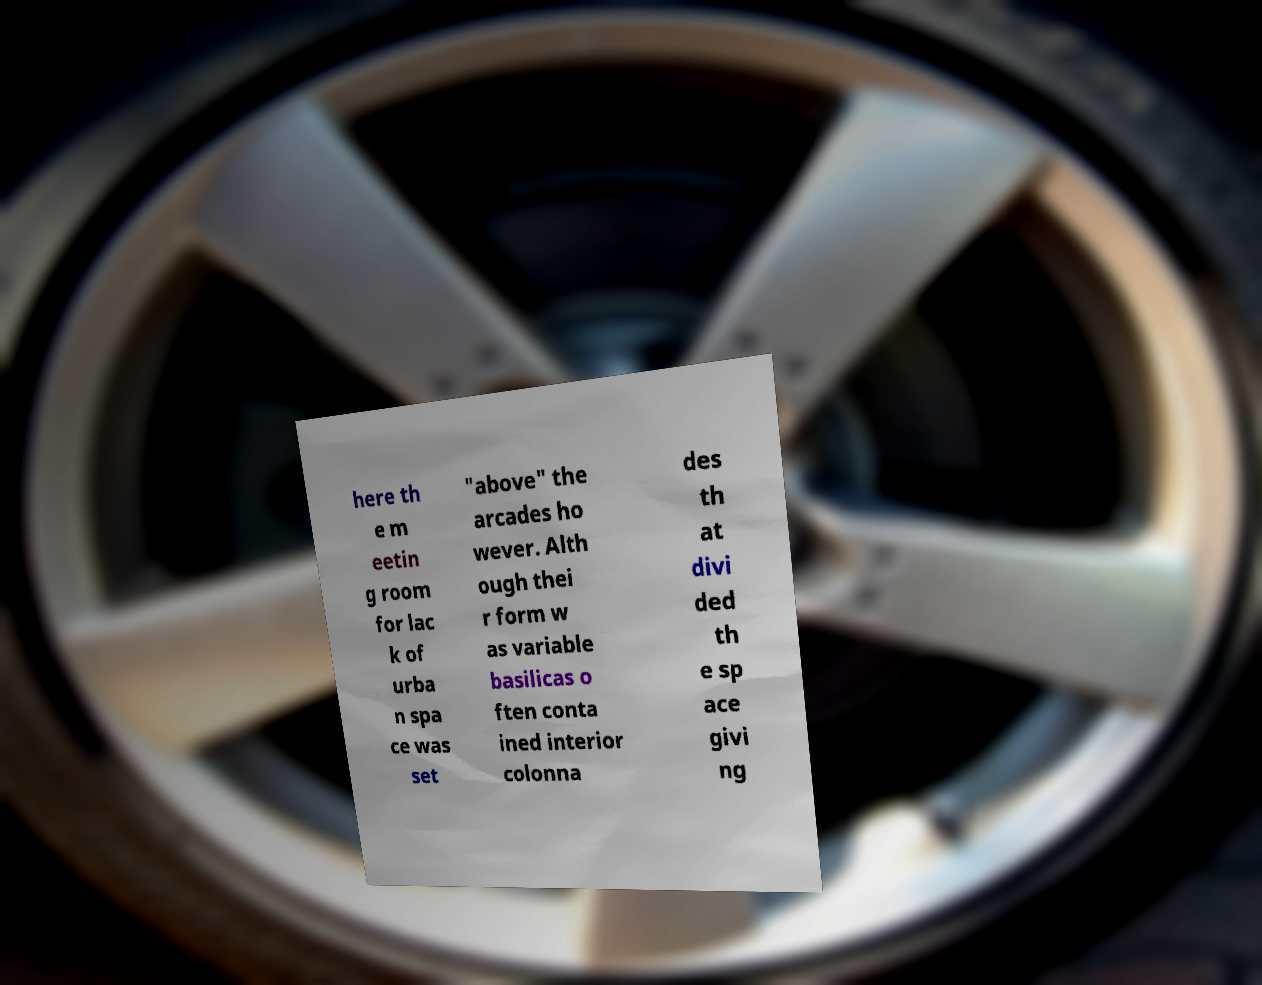Please identify and transcribe the text found in this image. here th e m eetin g room for lac k of urba n spa ce was set "above" the arcades ho wever. Alth ough thei r form w as variable basilicas o ften conta ined interior colonna des th at divi ded th e sp ace givi ng 